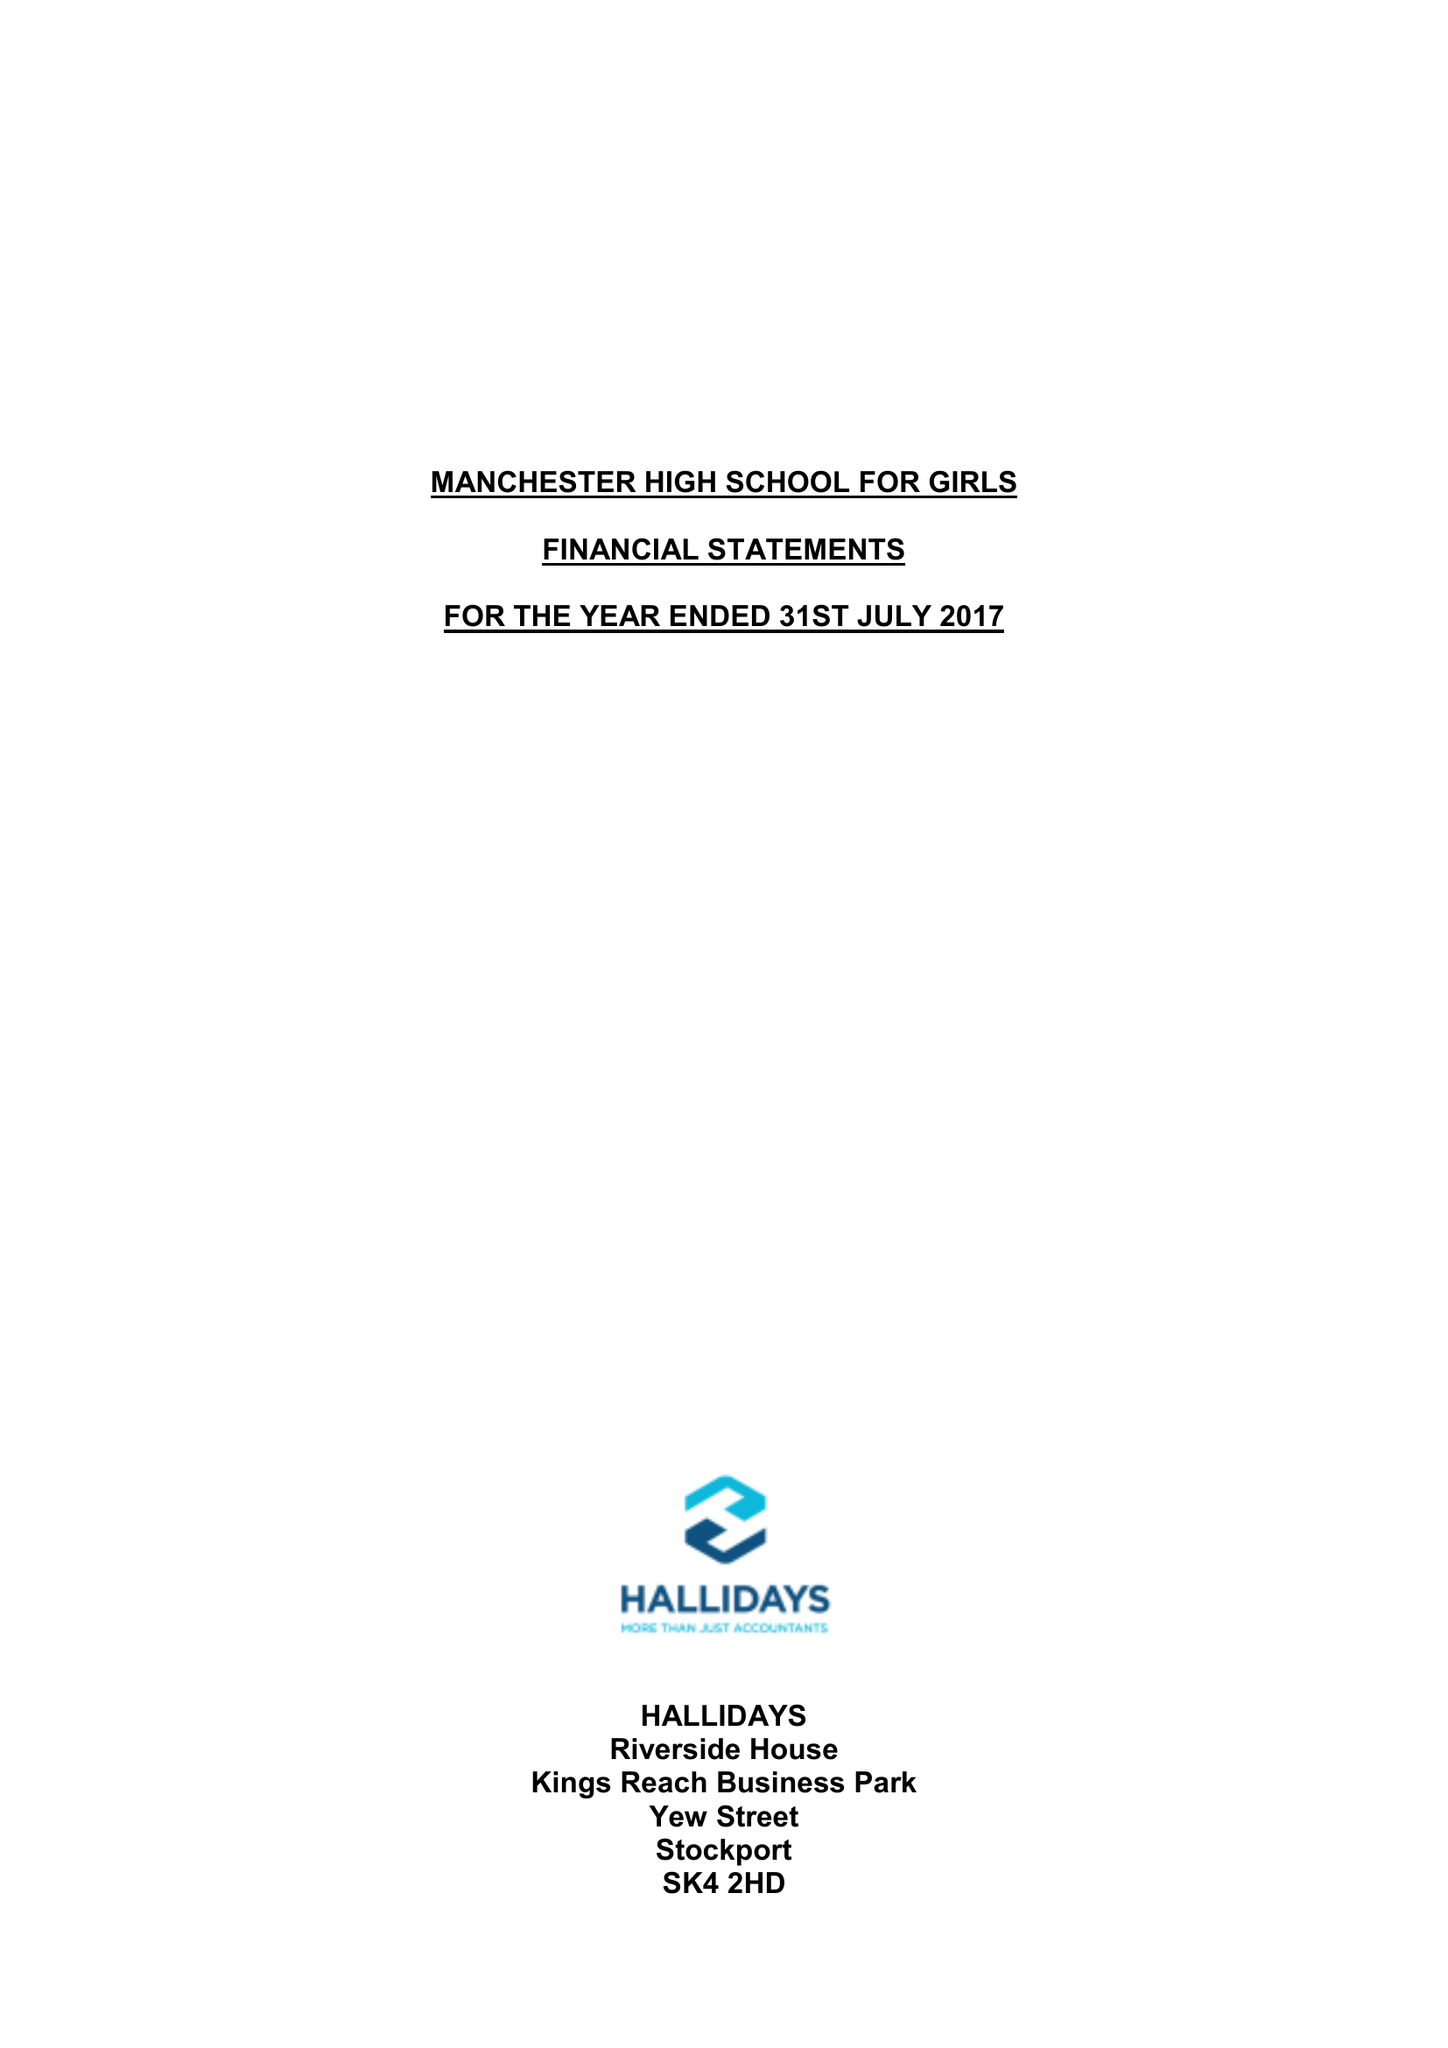What is the value for the spending_annually_in_british_pounds?
Answer the question using a single word or phrase. 10110633.00 